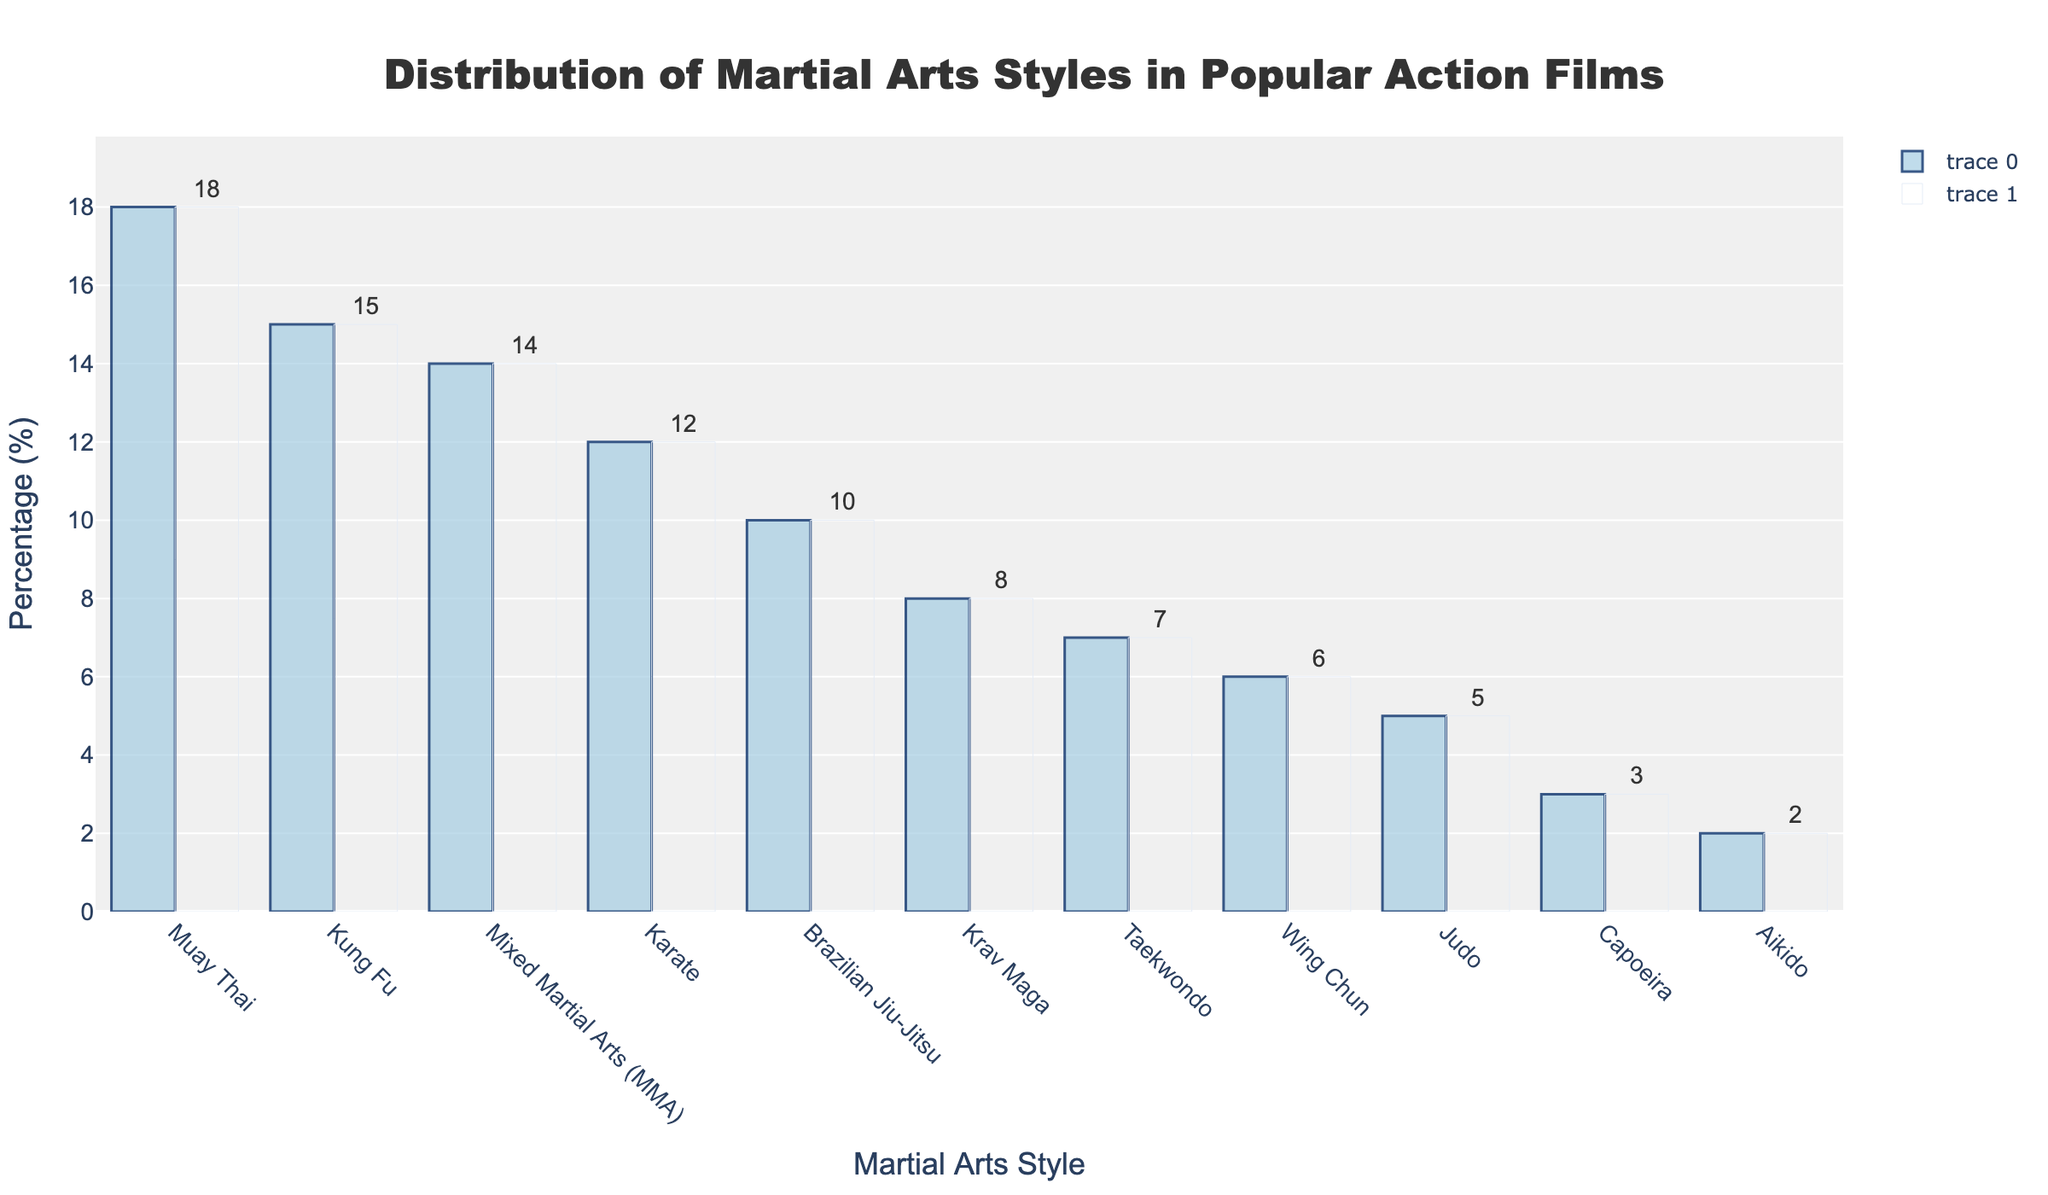Which martial arts style is most frequently depicted in action films? The bar corresponding to "Muay Thai" is the tallest in the chart, indicating it is the most frequently depicted martial arts style.
Answer: Muay Thai What is the cumulative percentage for martial arts styles ranked third and fourth? The third and fourth styles are Mixed Martial Arts (MMA) and Karate, with percentages of 14% and 12% respectively. Adding these gives 14 + 12 = 26%.
Answer: 26% How much less frequent is Brazilian Jiu-Jitsu compared to Muay Thai? Brazilian Jiu-Jitsu has 10% and Muay Thai has 18%. The difference is 18 - 10 = 8%.
Answer: 8% Of the martial arts styles listed, which is depicted exactly half as often as Karate? Karate has 12%, so half of that is 12 / 2 = 6%. The style with 6% is Wing Chun.
Answer: Wing Chun Which martial arts style shows a percentage close to the cumulative percentage of Capoeira and Aikido? Capoeira has 3% and Aikido has 2%. Their cumulative percentage is 3 + 2 = 5%. The style with 5% is Judo.
Answer: Judo Between Krav Maga and Taekwondo, which has a higher percentage? By how much? Krav Maga has 8% and Taekwondo has 7%. Krav Maga is higher by 8 - 7 = 1%.
Answer: Krav Maga, 1% Which styles have percentages that add up to exactly 25%? Wing Chun, Judo, Capoeira, and Aikido have percentages of 6%, 5%, 3%, and 2% respectively. Summing these: 6 + 5 + 3 + 2 = 16%, so this is not it. Taekwondo, Krav Maga, and Brazilian Jiu-Jitsu have percentages of 7%, 8%, and 10% respectively. Summing these: 7 + 8 + 10 = 25%.
Answer: Taekwondo, Krav Maga, Brazilian Jiu-Jitsu What is the combined percentage of the least frequent three martial arts styles? The least frequent three are Capoeira (3%), Aikido (2%), and Judo (5%). Adding these: 3 + 2 + 5 = 10%.
Answer: 10% Which martial arts styles have a percentage equal to twice that of Aikido? Aikido is at 2%, and twice that is 2 * 2 = 4%. No martial art is exactly at 4%, so none match this.
Answer: None 